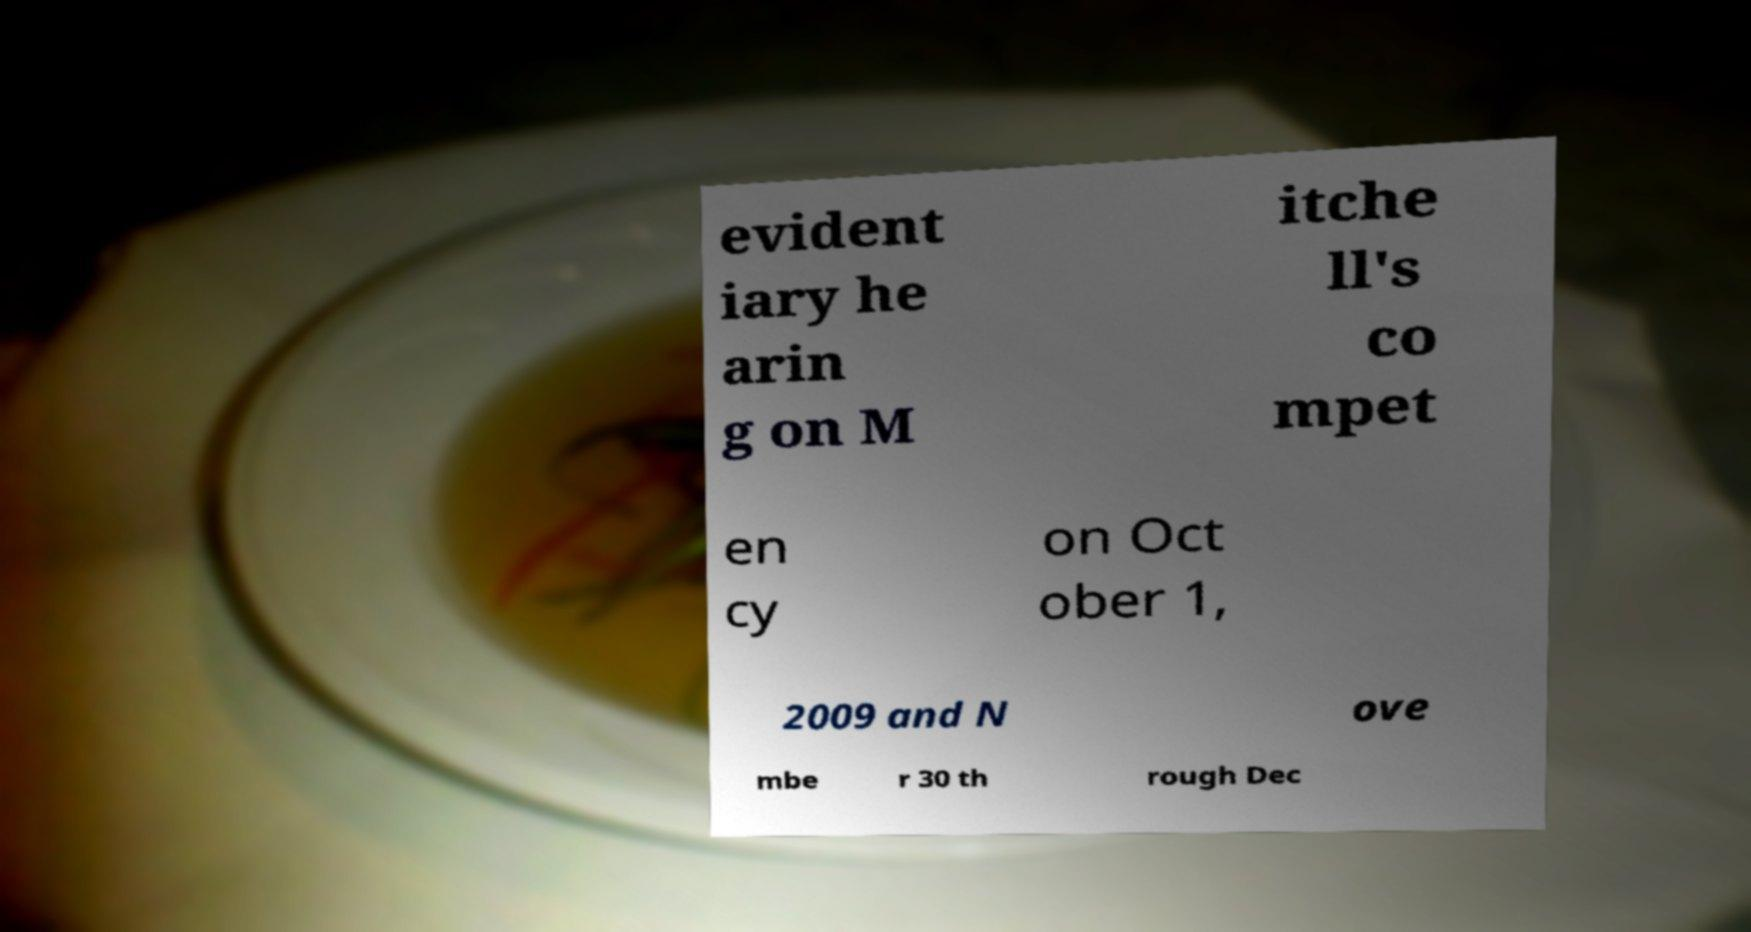What messages or text are displayed in this image? I need them in a readable, typed format. evident iary he arin g on M itche ll's co mpet en cy on Oct ober 1, 2009 and N ove mbe r 30 th rough Dec 